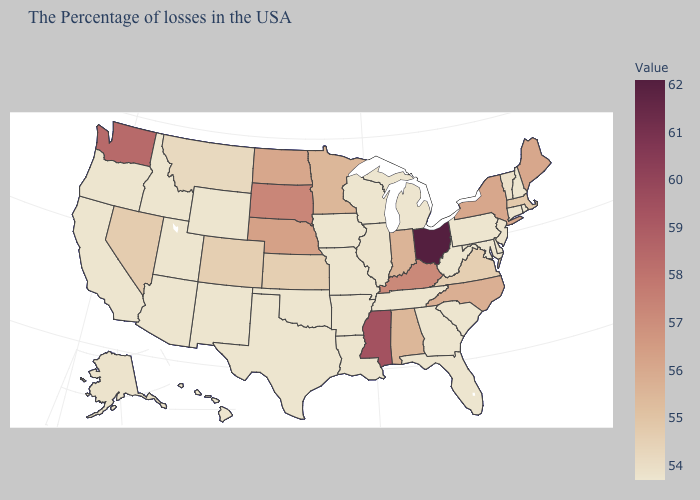Which states have the lowest value in the MidWest?
Short answer required. Michigan, Wisconsin, Missouri, Iowa. Does New York have the lowest value in the Northeast?
Give a very brief answer. No. Does Ohio have the highest value in the MidWest?
Keep it brief. Yes. Does Ohio have the highest value in the USA?
Write a very short answer. Yes. Does Iowa have the lowest value in the MidWest?
Keep it brief. Yes. 